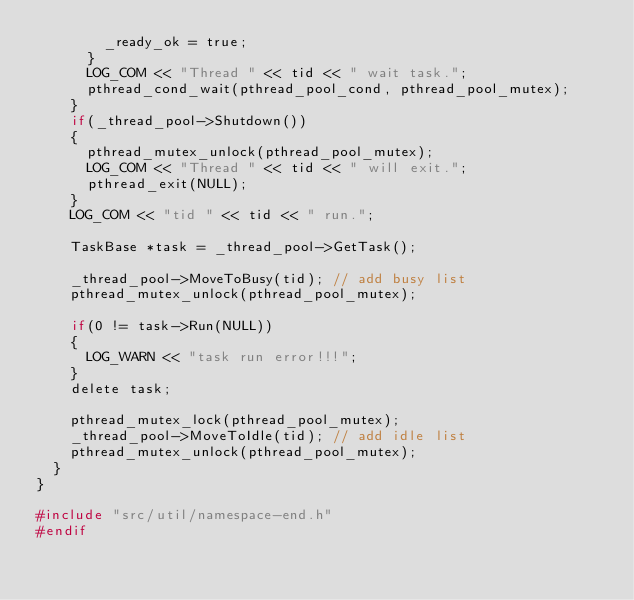Convert code to text. <code><loc_0><loc_0><loc_500><loc_500><_C_>				_ready_ok = true;
			}			
			LOG_COM << "Thread " << tid << " wait task.";
			pthread_cond_wait(pthread_pool_cond, pthread_pool_mutex);
		}
		if(_thread_pool->Shutdown())
		{
			pthread_mutex_unlock(pthread_pool_mutex);
			LOG_COM << "Thread " << tid << " will exit.";
			pthread_exit(NULL);
		}
		LOG_COM << "tid " << tid << " run.";

		TaskBase *task = _thread_pool->GetTask();

		_thread_pool->MoveToBusy(tid); // add busy list
		pthread_mutex_unlock(pthread_pool_mutex);

		if(0 != task->Run(NULL))
		{
			LOG_WARN << "task run error!!!";
		}
		delete task;

		pthread_mutex_lock(pthread_pool_mutex);
		_thread_pool->MoveToIdle(tid); // add idle list
		pthread_mutex_unlock(pthread_pool_mutex);
	}
}

#include "src/util/namespace-end.h"
#endif
</code> 